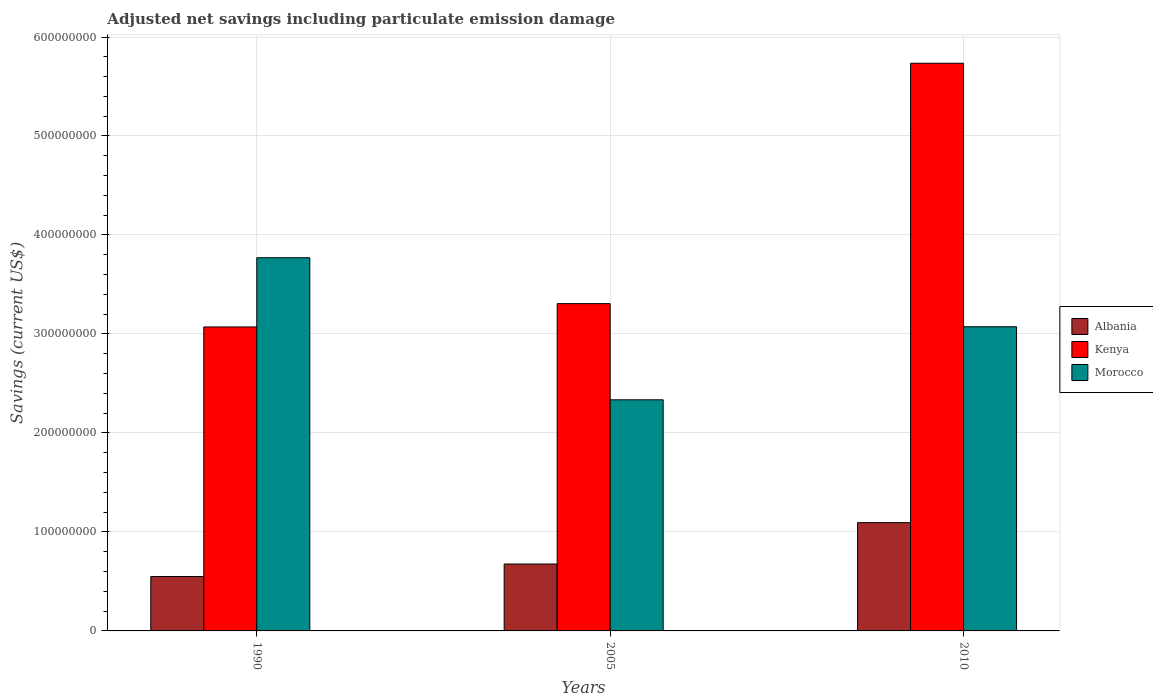How many different coloured bars are there?
Offer a very short reply. 3. Are the number of bars per tick equal to the number of legend labels?
Provide a short and direct response. Yes. Are the number of bars on each tick of the X-axis equal?
Your answer should be very brief. Yes. How many bars are there on the 3rd tick from the right?
Offer a terse response. 3. What is the net savings in Albania in 1990?
Provide a short and direct response. 5.50e+07. Across all years, what is the maximum net savings in Albania?
Ensure brevity in your answer.  1.09e+08. Across all years, what is the minimum net savings in Morocco?
Ensure brevity in your answer.  2.33e+08. What is the total net savings in Morocco in the graph?
Make the answer very short. 9.18e+08. What is the difference between the net savings in Albania in 2005 and that in 2010?
Your answer should be compact. -4.18e+07. What is the difference between the net savings in Morocco in 2005 and the net savings in Albania in 1990?
Make the answer very short. 1.79e+08. What is the average net savings in Morocco per year?
Give a very brief answer. 3.06e+08. In the year 1990, what is the difference between the net savings in Albania and net savings in Kenya?
Your response must be concise. -2.52e+08. What is the ratio of the net savings in Morocco in 1990 to that in 2010?
Make the answer very short. 1.23. Is the difference between the net savings in Albania in 2005 and 2010 greater than the difference between the net savings in Kenya in 2005 and 2010?
Ensure brevity in your answer.  Yes. What is the difference between the highest and the second highest net savings in Kenya?
Your answer should be compact. 2.43e+08. What is the difference between the highest and the lowest net savings in Kenya?
Provide a short and direct response. 2.66e+08. In how many years, is the net savings in Albania greater than the average net savings in Albania taken over all years?
Give a very brief answer. 1. What does the 1st bar from the left in 2010 represents?
Offer a very short reply. Albania. What does the 1st bar from the right in 2005 represents?
Your answer should be very brief. Morocco. How many bars are there?
Provide a short and direct response. 9. What is the difference between two consecutive major ticks on the Y-axis?
Your answer should be compact. 1.00e+08. Are the values on the major ticks of Y-axis written in scientific E-notation?
Make the answer very short. No. Where does the legend appear in the graph?
Provide a short and direct response. Center right. How many legend labels are there?
Your answer should be compact. 3. What is the title of the graph?
Offer a very short reply. Adjusted net savings including particulate emission damage. Does "Georgia" appear as one of the legend labels in the graph?
Ensure brevity in your answer.  No. What is the label or title of the X-axis?
Offer a terse response. Years. What is the label or title of the Y-axis?
Your answer should be very brief. Savings (current US$). What is the Savings (current US$) of Albania in 1990?
Keep it short and to the point. 5.50e+07. What is the Savings (current US$) of Kenya in 1990?
Ensure brevity in your answer.  3.07e+08. What is the Savings (current US$) in Morocco in 1990?
Offer a terse response. 3.77e+08. What is the Savings (current US$) of Albania in 2005?
Offer a terse response. 6.76e+07. What is the Savings (current US$) in Kenya in 2005?
Give a very brief answer. 3.31e+08. What is the Savings (current US$) of Morocco in 2005?
Provide a short and direct response. 2.33e+08. What is the Savings (current US$) in Albania in 2010?
Keep it short and to the point. 1.09e+08. What is the Savings (current US$) of Kenya in 2010?
Make the answer very short. 5.73e+08. What is the Savings (current US$) in Morocco in 2010?
Give a very brief answer. 3.07e+08. Across all years, what is the maximum Savings (current US$) of Albania?
Keep it short and to the point. 1.09e+08. Across all years, what is the maximum Savings (current US$) in Kenya?
Ensure brevity in your answer.  5.73e+08. Across all years, what is the maximum Savings (current US$) in Morocco?
Offer a terse response. 3.77e+08. Across all years, what is the minimum Savings (current US$) of Albania?
Your answer should be very brief. 5.50e+07. Across all years, what is the minimum Savings (current US$) in Kenya?
Make the answer very short. 3.07e+08. Across all years, what is the minimum Savings (current US$) in Morocco?
Your answer should be very brief. 2.33e+08. What is the total Savings (current US$) of Albania in the graph?
Make the answer very short. 2.32e+08. What is the total Savings (current US$) in Kenya in the graph?
Provide a short and direct response. 1.21e+09. What is the total Savings (current US$) in Morocco in the graph?
Ensure brevity in your answer.  9.18e+08. What is the difference between the Savings (current US$) of Albania in 1990 and that in 2005?
Ensure brevity in your answer.  -1.26e+07. What is the difference between the Savings (current US$) in Kenya in 1990 and that in 2005?
Your response must be concise. -2.35e+07. What is the difference between the Savings (current US$) of Morocco in 1990 and that in 2005?
Ensure brevity in your answer.  1.44e+08. What is the difference between the Savings (current US$) of Albania in 1990 and that in 2010?
Provide a short and direct response. -5.44e+07. What is the difference between the Savings (current US$) of Kenya in 1990 and that in 2010?
Keep it short and to the point. -2.66e+08. What is the difference between the Savings (current US$) in Morocco in 1990 and that in 2010?
Provide a succinct answer. 6.97e+07. What is the difference between the Savings (current US$) in Albania in 2005 and that in 2010?
Your response must be concise. -4.18e+07. What is the difference between the Savings (current US$) in Kenya in 2005 and that in 2010?
Your answer should be compact. -2.43e+08. What is the difference between the Savings (current US$) of Morocco in 2005 and that in 2010?
Your response must be concise. -7.38e+07. What is the difference between the Savings (current US$) in Albania in 1990 and the Savings (current US$) in Kenya in 2005?
Ensure brevity in your answer.  -2.76e+08. What is the difference between the Savings (current US$) of Albania in 1990 and the Savings (current US$) of Morocco in 2005?
Provide a short and direct response. -1.79e+08. What is the difference between the Savings (current US$) of Kenya in 1990 and the Savings (current US$) of Morocco in 2005?
Keep it short and to the point. 7.36e+07. What is the difference between the Savings (current US$) in Albania in 1990 and the Savings (current US$) in Kenya in 2010?
Give a very brief answer. -5.19e+08. What is the difference between the Savings (current US$) of Albania in 1990 and the Savings (current US$) of Morocco in 2010?
Give a very brief answer. -2.52e+08. What is the difference between the Savings (current US$) of Kenya in 1990 and the Savings (current US$) of Morocco in 2010?
Provide a short and direct response. -2.10e+05. What is the difference between the Savings (current US$) of Albania in 2005 and the Savings (current US$) of Kenya in 2010?
Make the answer very short. -5.06e+08. What is the difference between the Savings (current US$) of Albania in 2005 and the Savings (current US$) of Morocco in 2010?
Make the answer very short. -2.40e+08. What is the difference between the Savings (current US$) in Kenya in 2005 and the Savings (current US$) in Morocco in 2010?
Give a very brief answer. 2.33e+07. What is the average Savings (current US$) of Albania per year?
Your answer should be compact. 7.73e+07. What is the average Savings (current US$) in Kenya per year?
Provide a succinct answer. 4.04e+08. What is the average Savings (current US$) of Morocco per year?
Make the answer very short. 3.06e+08. In the year 1990, what is the difference between the Savings (current US$) of Albania and Savings (current US$) of Kenya?
Your response must be concise. -2.52e+08. In the year 1990, what is the difference between the Savings (current US$) in Albania and Savings (current US$) in Morocco?
Ensure brevity in your answer.  -3.22e+08. In the year 1990, what is the difference between the Savings (current US$) in Kenya and Savings (current US$) in Morocco?
Offer a very short reply. -6.99e+07. In the year 2005, what is the difference between the Savings (current US$) of Albania and Savings (current US$) of Kenya?
Provide a short and direct response. -2.63e+08. In the year 2005, what is the difference between the Savings (current US$) in Albania and Savings (current US$) in Morocco?
Provide a short and direct response. -1.66e+08. In the year 2005, what is the difference between the Savings (current US$) in Kenya and Savings (current US$) in Morocco?
Provide a succinct answer. 9.71e+07. In the year 2010, what is the difference between the Savings (current US$) in Albania and Savings (current US$) in Kenya?
Provide a succinct answer. -4.64e+08. In the year 2010, what is the difference between the Savings (current US$) of Albania and Savings (current US$) of Morocco?
Provide a short and direct response. -1.98e+08. In the year 2010, what is the difference between the Savings (current US$) of Kenya and Savings (current US$) of Morocco?
Provide a short and direct response. 2.66e+08. What is the ratio of the Savings (current US$) in Albania in 1990 to that in 2005?
Ensure brevity in your answer.  0.81. What is the ratio of the Savings (current US$) in Kenya in 1990 to that in 2005?
Provide a short and direct response. 0.93. What is the ratio of the Savings (current US$) in Morocco in 1990 to that in 2005?
Your answer should be very brief. 1.61. What is the ratio of the Savings (current US$) of Albania in 1990 to that in 2010?
Your answer should be compact. 0.5. What is the ratio of the Savings (current US$) of Kenya in 1990 to that in 2010?
Offer a terse response. 0.54. What is the ratio of the Savings (current US$) of Morocco in 1990 to that in 2010?
Your answer should be very brief. 1.23. What is the ratio of the Savings (current US$) of Albania in 2005 to that in 2010?
Your answer should be compact. 0.62. What is the ratio of the Savings (current US$) in Kenya in 2005 to that in 2010?
Ensure brevity in your answer.  0.58. What is the ratio of the Savings (current US$) of Morocco in 2005 to that in 2010?
Ensure brevity in your answer.  0.76. What is the difference between the highest and the second highest Savings (current US$) in Albania?
Offer a very short reply. 4.18e+07. What is the difference between the highest and the second highest Savings (current US$) in Kenya?
Your answer should be very brief. 2.43e+08. What is the difference between the highest and the second highest Savings (current US$) of Morocco?
Offer a terse response. 6.97e+07. What is the difference between the highest and the lowest Savings (current US$) in Albania?
Make the answer very short. 5.44e+07. What is the difference between the highest and the lowest Savings (current US$) of Kenya?
Provide a succinct answer. 2.66e+08. What is the difference between the highest and the lowest Savings (current US$) of Morocco?
Keep it short and to the point. 1.44e+08. 